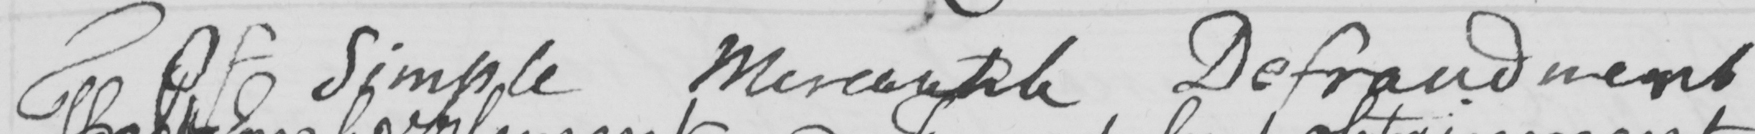Transcribe the text shown in this historical manuscript line. Of Simple Mercantile Defraudment 